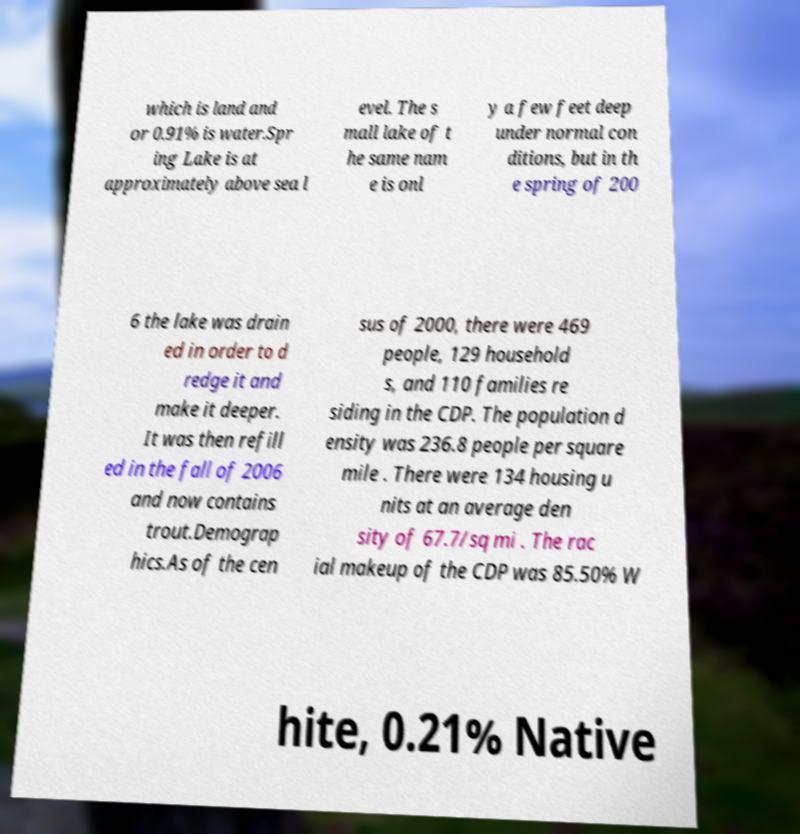Can you read and provide the text displayed in the image?This photo seems to have some interesting text. Can you extract and type it out for me? which is land and or 0.91% is water.Spr ing Lake is at approximately above sea l evel. The s mall lake of t he same nam e is onl y a few feet deep under normal con ditions, but in th e spring of 200 6 the lake was drain ed in order to d redge it and make it deeper. It was then refill ed in the fall of 2006 and now contains trout.Demograp hics.As of the cen sus of 2000, there were 469 people, 129 household s, and 110 families re siding in the CDP. The population d ensity was 236.8 people per square mile . There were 134 housing u nits at an average den sity of 67.7/sq mi . The rac ial makeup of the CDP was 85.50% W hite, 0.21% Native 